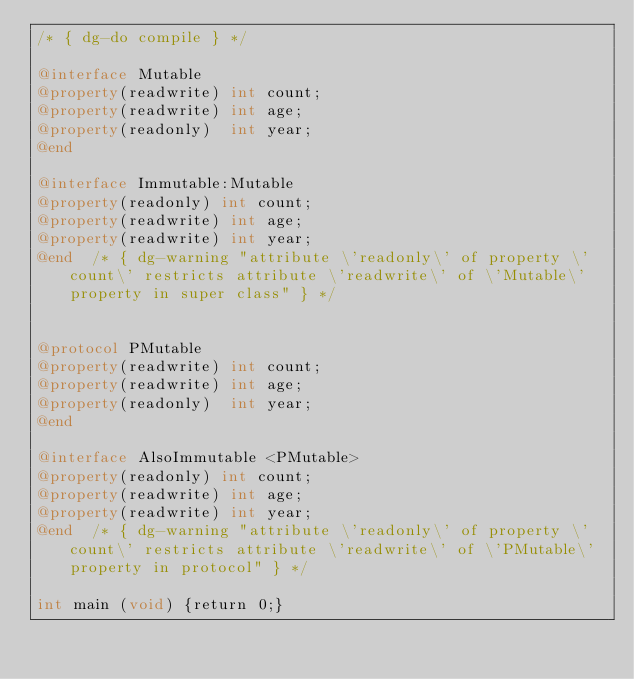Convert code to text. <code><loc_0><loc_0><loc_500><loc_500><_ObjectiveC_>/* { dg-do compile } */

@interface Mutable
@property(readwrite) int count;
@property(readwrite) int age;
@property(readonly)  int year;
@end

@interface Immutable:Mutable
@property(readonly) int count;
@property(readwrite) int age;
@property(readwrite) int year;
@end	/* { dg-warning "attribute \'readonly\' of property \'count\' restricts attribute \'readwrite\' of \'Mutable\' property in super class" } */


@protocol PMutable
@property(readwrite) int count;
@property(readwrite) int age;
@property(readonly)  int year;
@end

@interface AlsoImmutable <PMutable>
@property(readonly) int count;
@property(readwrite) int age;
@property(readwrite) int year;
@end	/* { dg-warning "attribute \'readonly\' of property \'count\' restricts attribute \'readwrite\' of \'PMutable\' property in protocol" } */

int main (void) {return 0;}

</code> 